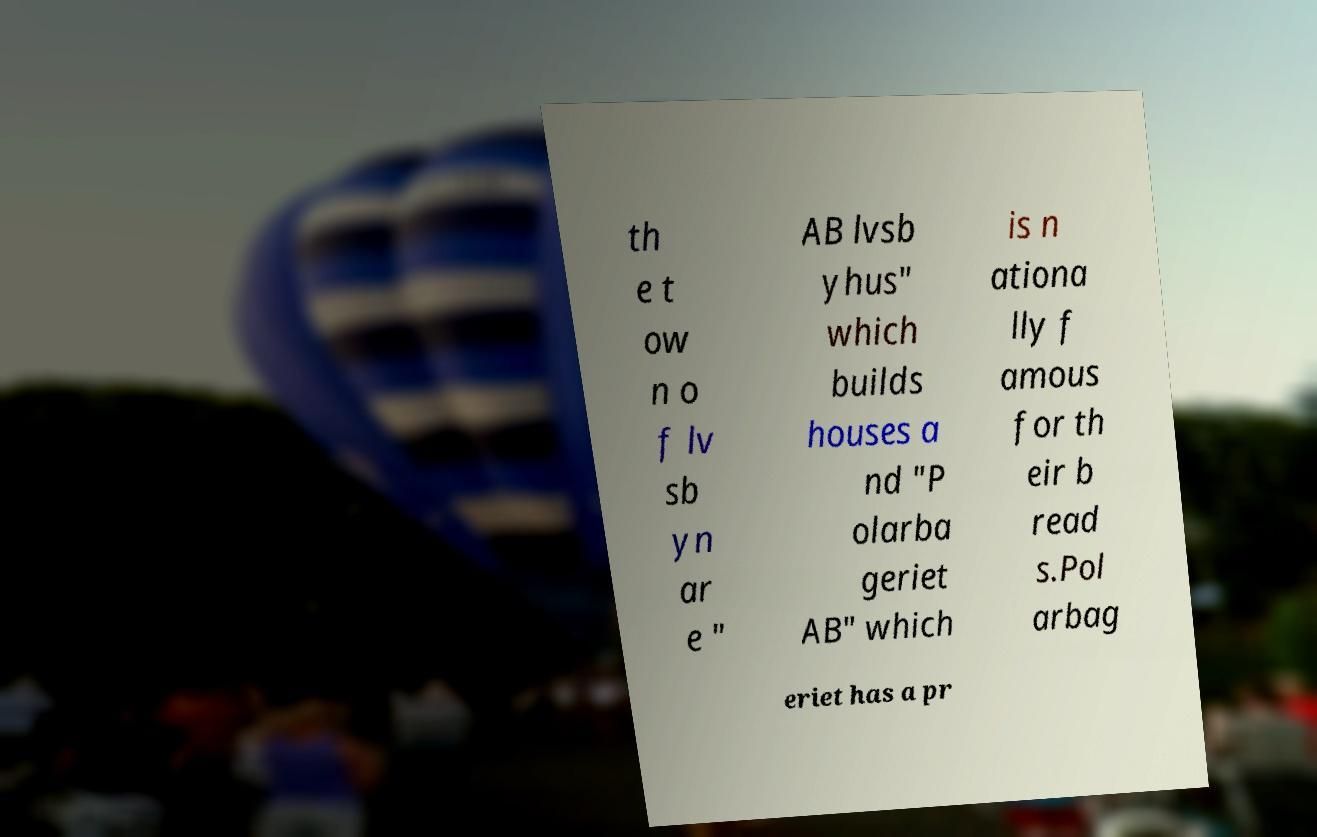Please identify and transcribe the text found in this image. th e t ow n o f lv sb yn ar e " AB lvsb yhus" which builds houses a nd "P olarba geriet AB" which is n ationa lly f amous for th eir b read s.Pol arbag eriet has a pr 